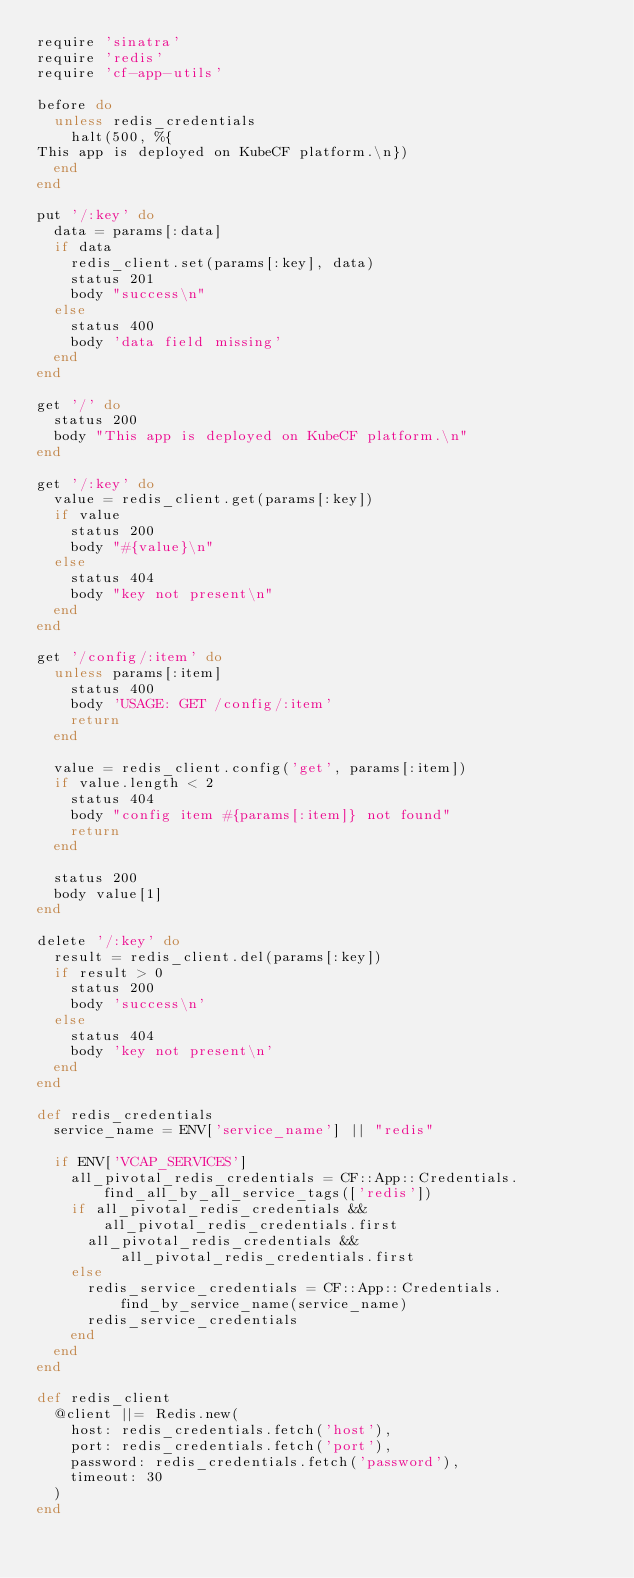<code> <loc_0><loc_0><loc_500><loc_500><_Ruby_>require 'sinatra'
require 'redis'
require 'cf-app-utils'

before do
  unless redis_credentials
    halt(500, %{
This app is deployed on KubeCF platform.\n})
  end
end

put '/:key' do
  data = params[:data]
  if data
    redis_client.set(params[:key], data)
    status 201
    body "success\n"
  else
    status 400
    body 'data field missing'
  end
end

get '/' do
  status 200
  body "This app is deployed on KubeCF platform.\n"
end

get '/:key' do
  value = redis_client.get(params[:key])
  if value
    status 200
    body "#{value}\n"
  else
    status 404
    body "key not present\n"
  end
end

get '/config/:item' do
  unless params[:item]
    status 400
    body 'USAGE: GET /config/:item'
    return
  end

  value = redis_client.config('get', params[:item])
  if value.length < 2
    status 404
    body "config item #{params[:item]} not found"
    return
  end

  status 200
  body value[1]
end

delete '/:key' do
  result = redis_client.del(params[:key])
  if result > 0
    status 200
    body 'success\n'
  else
    status 404
    body 'key not present\n'
  end
end

def redis_credentials
  service_name = ENV['service_name'] || "redis"

  if ENV['VCAP_SERVICES']
    all_pivotal_redis_credentials = CF::App::Credentials.find_all_by_all_service_tags(['redis'])
    if all_pivotal_redis_credentials && all_pivotal_redis_credentials.first
      all_pivotal_redis_credentials && all_pivotal_redis_credentials.first
    else
      redis_service_credentials = CF::App::Credentials.find_by_service_name(service_name)
      redis_service_credentials
    end
  end
end

def redis_client
  @client ||= Redis.new(
    host: redis_credentials.fetch('host'),
    port: redis_credentials.fetch('port'),
    password: redis_credentials.fetch('password'),
    timeout: 30
  )
end
</code> 